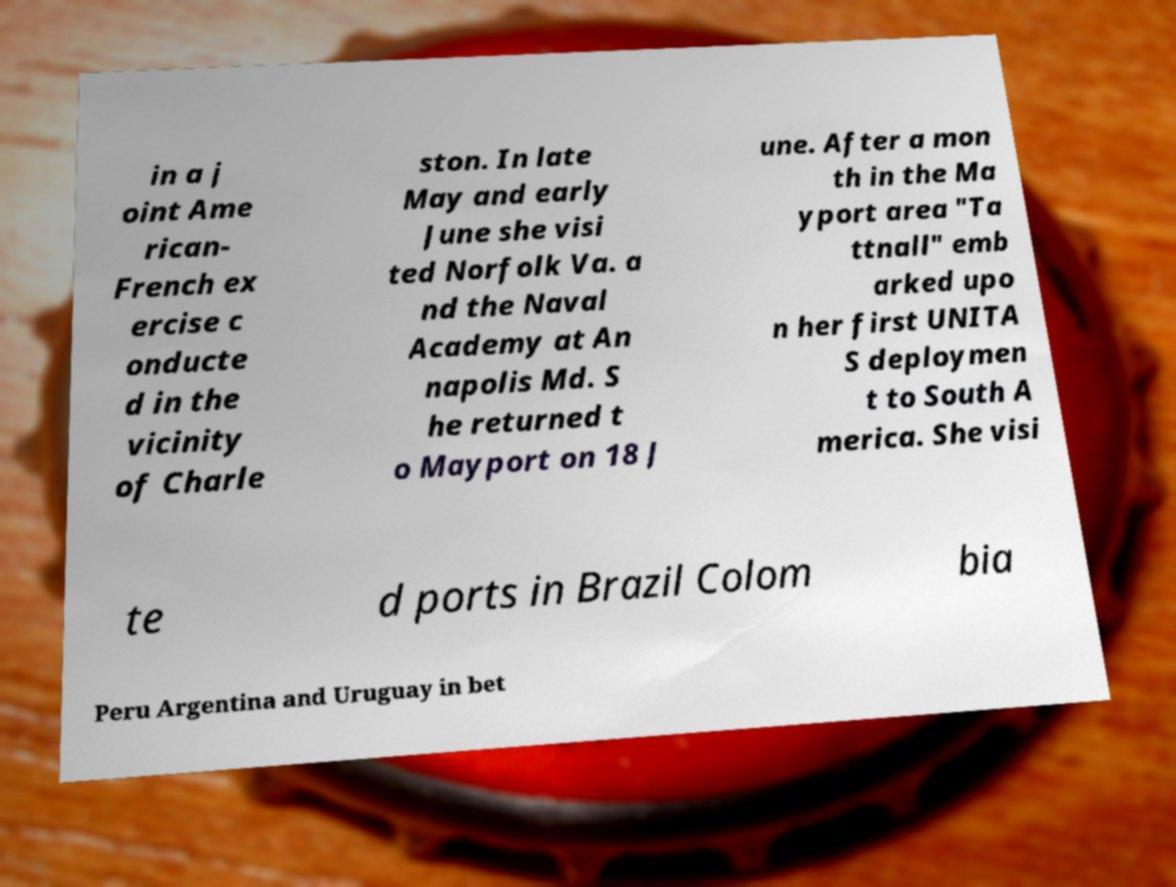There's text embedded in this image that I need extracted. Can you transcribe it verbatim? in a j oint Ame rican- French ex ercise c onducte d in the vicinity of Charle ston. In late May and early June she visi ted Norfolk Va. a nd the Naval Academy at An napolis Md. S he returned t o Mayport on 18 J une. After a mon th in the Ma yport area "Ta ttnall" emb arked upo n her first UNITA S deploymen t to South A merica. She visi te d ports in Brazil Colom bia Peru Argentina and Uruguay in bet 